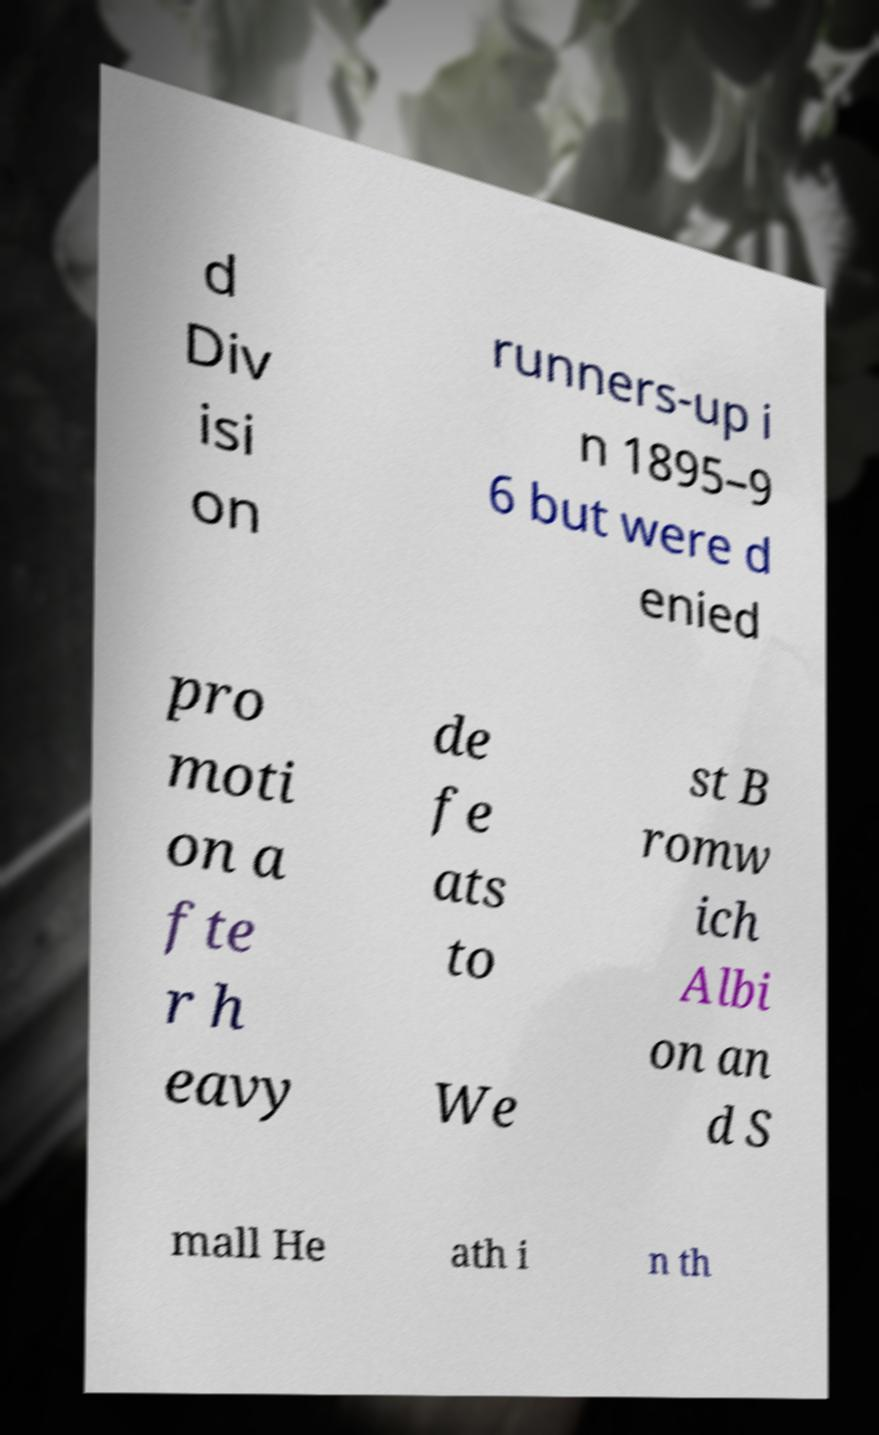Please read and relay the text visible in this image. What does it say? d Div isi on runners-up i n 1895–9 6 but were d enied pro moti on a fte r h eavy de fe ats to We st B romw ich Albi on an d S mall He ath i n th 